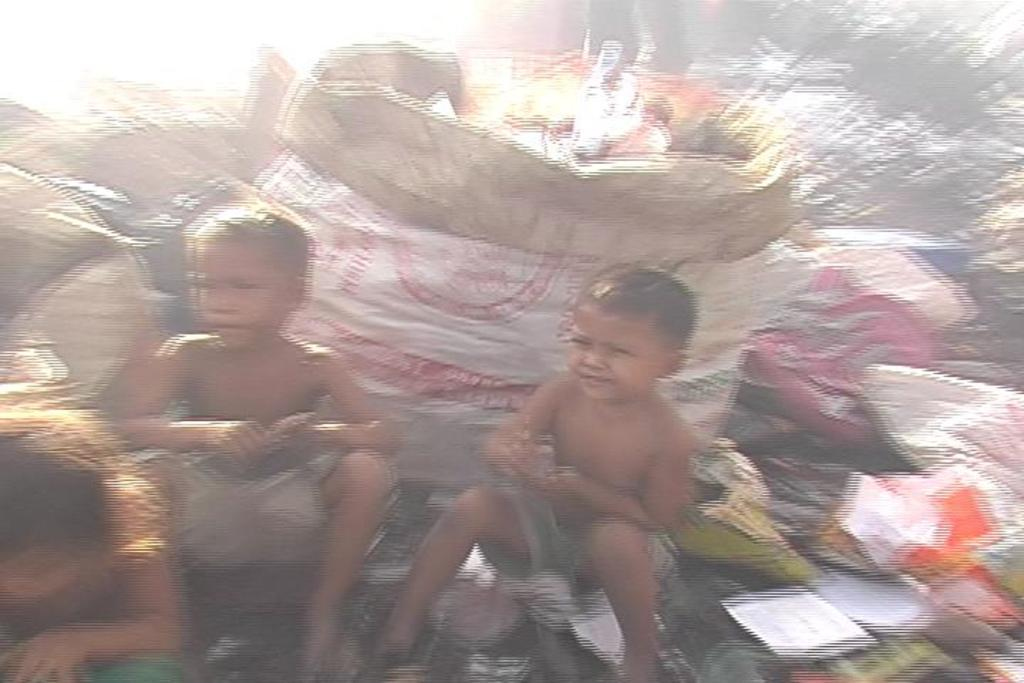What can be seen in the image involving children? There are children sitting in the image. What is the purpose of the bags in the image? The bags contain trash and scrap in the image. Where are the bags located in the image? The bags are on the ground in the image. How do the children say good-bye to each other in the image? There is no indication in the image of the children saying good-bye to each other. What type of cork is used to seal the bags in the image? There are no corks present in the image, as the bags are not sealed with corks. 